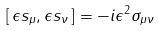Convert formula to latex. <formula><loc_0><loc_0><loc_500><loc_500>[ \, \epsilon s _ { \mu } , \epsilon s _ { \nu } \, ] = - i \epsilon ^ { 2 } \sigma _ { \mu \nu }</formula> 